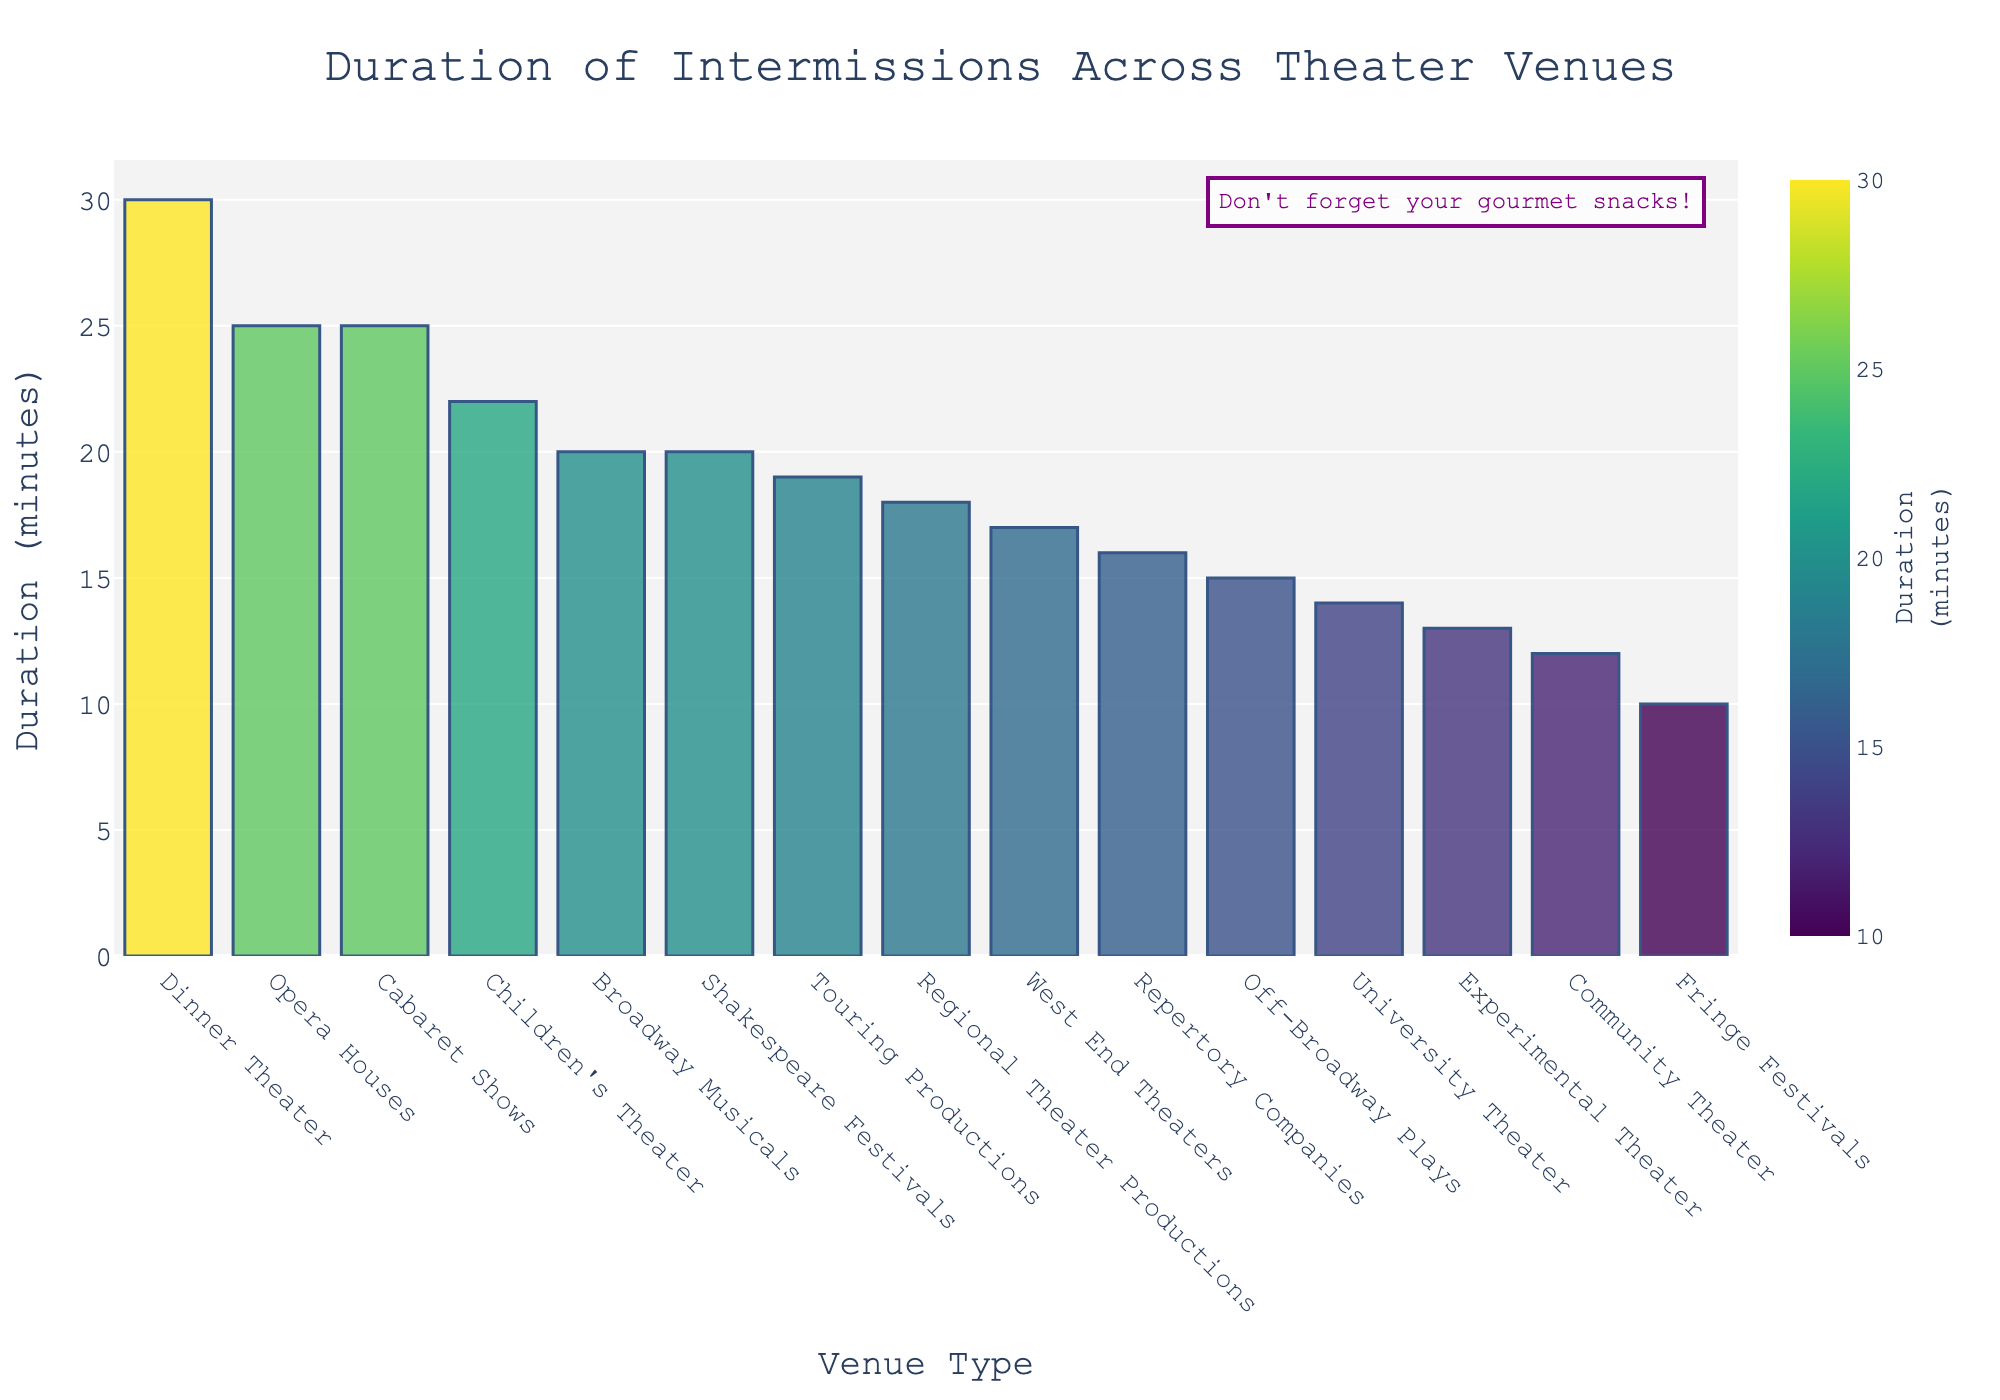Which theater type has the longest average intermission duration? Look at the bar with the greatest height, corresponding to the longest duration on the y-axis. The highest bar is associated with Dinner Theater, indicating it has the longest average intermission duration.
Answer: Dinner Theater How much longer is the average intermission duration at Opera Houses compared to Off-Broadway Plays? Find the height of the bars corresponding to Opera Houses and Off-Broadway Plays. Opera Houses have an intermission duration of 25 minutes, and Off-Broadway Plays have 15 minutes. Subtract 15 from 25 to find the difference.
Answer: 10 minutes What is the average intermission duration for all theater types combined? Add the average intermission durations for all theater types and divide by the number of theater types. Sum: 20 + 15 + 18 + 25 + 12 + 17 + 10 + 30 + 16 + 13 + 22 + 20 + 14 + 19 + 25 = 276. Number of types: 15. Average: 276 / 15 = 18.4
Answer: 18.4 minutes Which two theater types have an equal average intermission duration? Look for bars of equal height. Both Broadway Musicals and Shakespeare Festivals have bars that represent 20 minutes.
Answer: Broadway Musicals and Shakespeare Festivals List all theater types with an average intermission duration less than 15 minutes. Identify bars that do not reach the 15-minute mark on the y-axis. These are Community Theater (12 minutes), Fringe Festivals (10 minutes), Experimental Theater (13 minutes), and University Theater (14 minutes).
Answer: Community Theater, Fringe Festivals, Experimental Theater, University Theater How much shorter is the average intermission duration for West End Theaters compared to Cabaret Shows? Find the average intermission durations for West End Theaters (17 minutes) and Cabaret Shows (25 minutes). Subtract 17 from 25 to get the difference.
Answer: 8 minutes Which theater type's average intermission duration is closest to the average duration calculated for all theater types combined? The overall average duration is 18.4 minutes. Identify the theater type with an intermission duration closest to this value. Regional Theater Productions have an average intermission duration of 18 minutes, which is closest to 18.4 minutes.
Answer: Regional Theater Productions What is the total intermission duration for the four theater types with the shortest durations? Add the average intermission durations for the four theater types with the shortest durations: Fringe Festivals (10 minutes), Community Theater (12 minutes), Experimental Theater (13 minutes), and University Theater (14 minutes). Total: 10 + 12 + 13 + 14 = 49 minutes.
Answer: 49 minutes Out of Broadway Musicals, Off-Broadway Plays, and Regional Theater Productions, which one has the longest average intermission duration? Compare the average intermission durations for Broadway Musicals (20 minutes), Off-Broadway Plays (15 minutes), and Regional Theater Productions (18 minutes). Broadway Musicals have the longest duration.
Answer: Broadway Musicals 